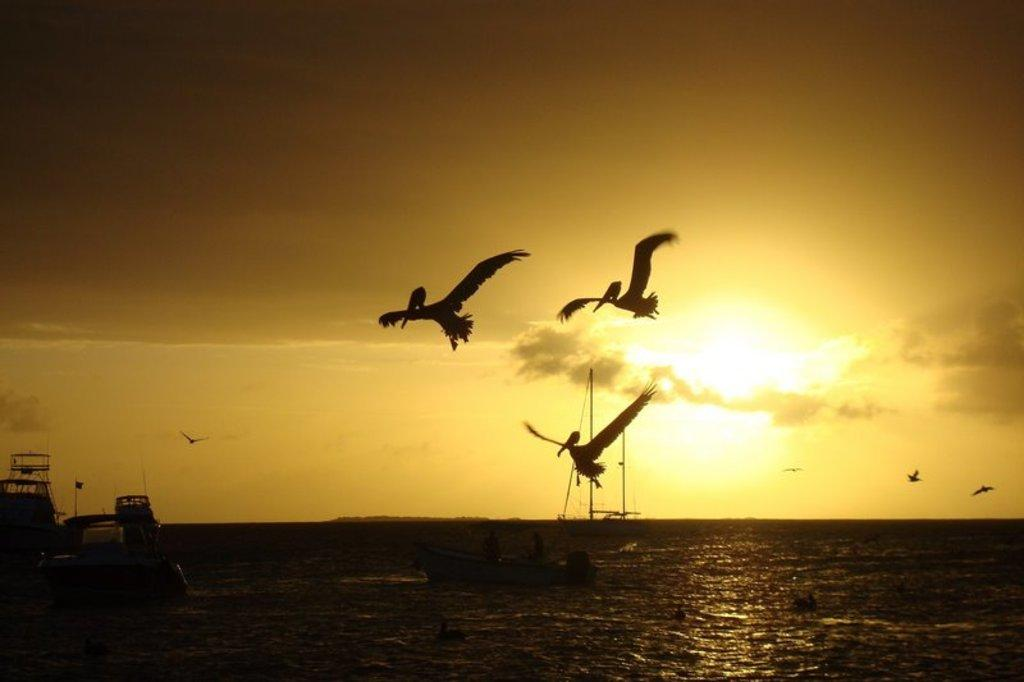What is happening in the sky in the image? There are birds flying in the sky in the image. Where are the birds located in relation to the sea? The birds are above the sea in the image. What can be seen in the sea besides the birds? There is a boat and a big ship sailing in the sea. What is visible in the background of the image? The sky is visible in the background of the image. How many pigs are swimming in the sea with the birds? There are no pigs present in the image; it only features birds, a boat, and a big ship sailing in the sea. What type of pet can be seen on the big ship? There is no pet visible on the big ship in the image. 